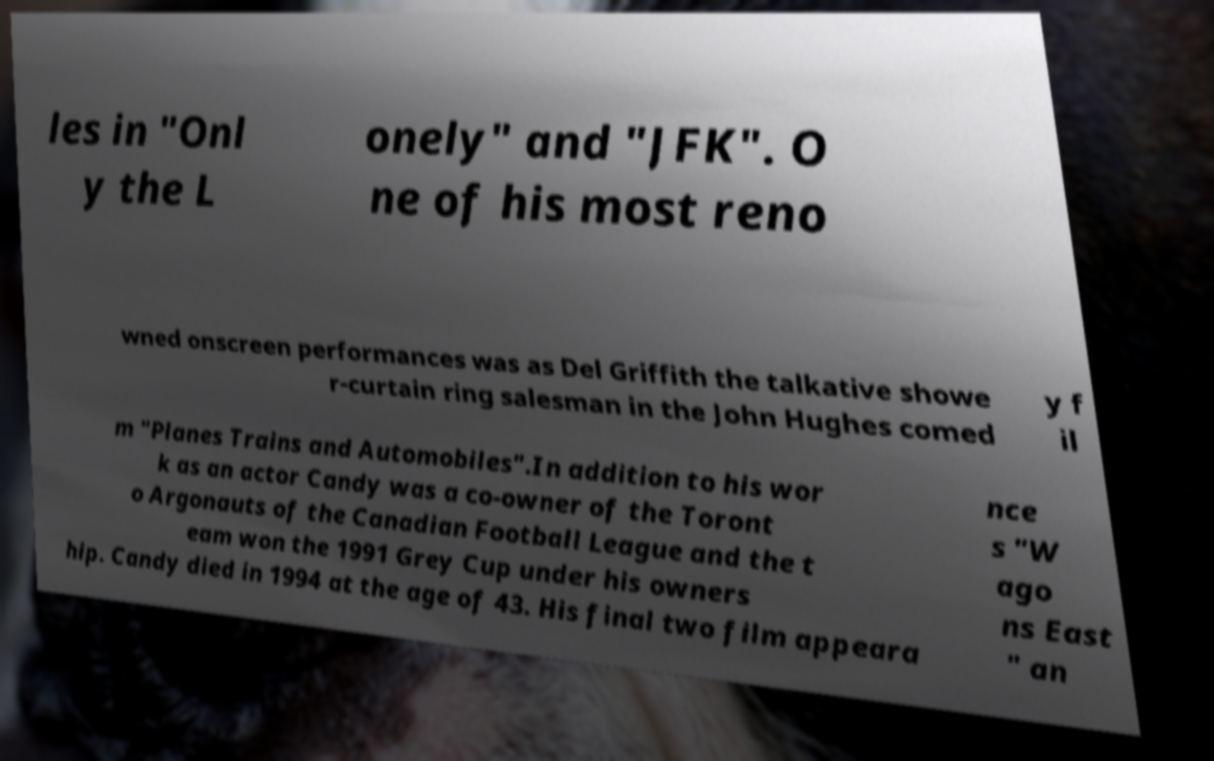What messages or text are displayed in this image? I need them in a readable, typed format. les in "Onl y the L onely" and "JFK". O ne of his most reno wned onscreen performances was as Del Griffith the talkative showe r-curtain ring salesman in the John Hughes comed y f il m "Planes Trains and Automobiles".In addition to his wor k as an actor Candy was a co-owner of the Toront o Argonauts of the Canadian Football League and the t eam won the 1991 Grey Cup under his owners hip. Candy died in 1994 at the age of 43. His final two film appeara nce s "W ago ns East " an 